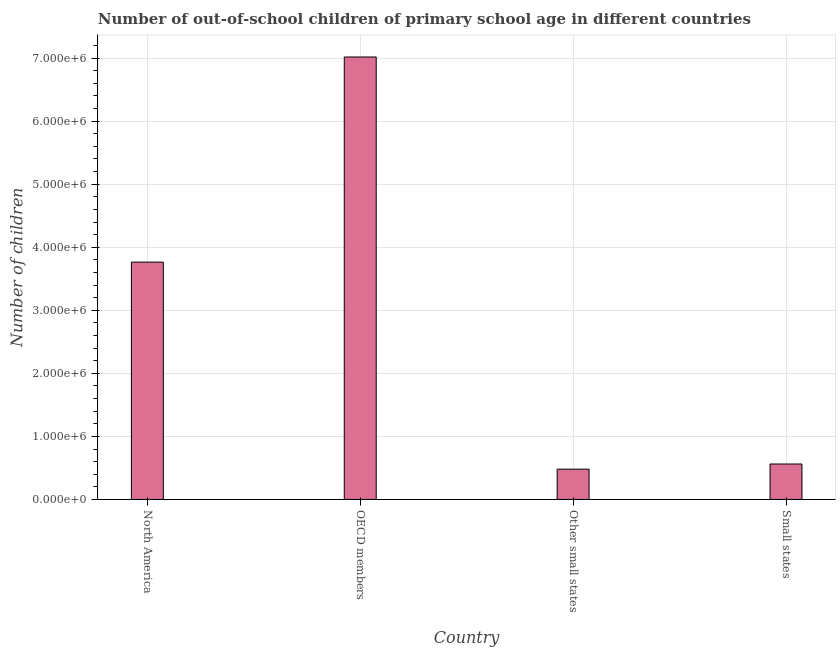What is the title of the graph?
Provide a short and direct response. Number of out-of-school children of primary school age in different countries. What is the label or title of the X-axis?
Your answer should be compact. Country. What is the label or title of the Y-axis?
Provide a succinct answer. Number of children. What is the number of out-of-school children in Small states?
Ensure brevity in your answer.  5.62e+05. Across all countries, what is the maximum number of out-of-school children?
Your answer should be compact. 7.02e+06. Across all countries, what is the minimum number of out-of-school children?
Keep it short and to the point. 4.81e+05. In which country was the number of out-of-school children minimum?
Make the answer very short. Other small states. What is the sum of the number of out-of-school children?
Your answer should be very brief. 1.18e+07. What is the difference between the number of out-of-school children in Other small states and Small states?
Provide a succinct answer. -8.16e+04. What is the average number of out-of-school children per country?
Your answer should be very brief. 2.96e+06. What is the median number of out-of-school children?
Ensure brevity in your answer.  2.16e+06. What is the ratio of the number of out-of-school children in OECD members to that in Small states?
Provide a short and direct response. 12.48. Is the number of out-of-school children in OECD members less than that in Small states?
Provide a succinct answer. No. Is the difference between the number of out-of-school children in Other small states and Small states greater than the difference between any two countries?
Your answer should be very brief. No. What is the difference between the highest and the second highest number of out-of-school children?
Offer a terse response. 3.25e+06. Is the sum of the number of out-of-school children in North America and Other small states greater than the maximum number of out-of-school children across all countries?
Give a very brief answer. No. What is the difference between the highest and the lowest number of out-of-school children?
Provide a short and direct response. 6.54e+06. In how many countries, is the number of out-of-school children greater than the average number of out-of-school children taken over all countries?
Offer a terse response. 2. How many countries are there in the graph?
Offer a terse response. 4. What is the Number of children in North America?
Your response must be concise. 3.76e+06. What is the Number of children of OECD members?
Provide a short and direct response. 7.02e+06. What is the Number of children of Other small states?
Offer a very short reply. 4.81e+05. What is the Number of children in Small states?
Provide a short and direct response. 5.62e+05. What is the difference between the Number of children in North America and OECD members?
Ensure brevity in your answer.  -3.25e+06. What is the difference between the Number of children in North America and Other small states?
Provide a succinct answer. 3.28e+06. What is the difference between the Number of children in North America and Small states?
Provide a succinct answer. 3.20e+06. What is the difference between the Number of children in OECD members and Other small states?
Your response must be concise. 6.54e+06. What is the difference between the Number of children in OECD members and Small states?
Your answer should be compact. 6.45e+06. What is the difference between the Number of children in Other small states and Small states?
Offer a terse response. -8.16e+04. What is the ratio of the Number of children in North America to that in OECD members?
Keep it short and to the point. 0.54. What is the ratio of the Number of children in North America to that in Other small states?
Offer a terse response. 7.83. What is the ratio of the Number of children in North America to that in Small states?
Ensure brevity in your answer.  6.7. What is the ratio of the Number of children in OECD members to that in Other small states?
Provide a short and direct response. 14.6. What is the ratio of the Number of children in OECD members to that in Small states?
Provide a succinct answer. 12.48. What is the ratio of the Number of children in Other small states to that in Small states?
Make the answer very short. 0.85. 